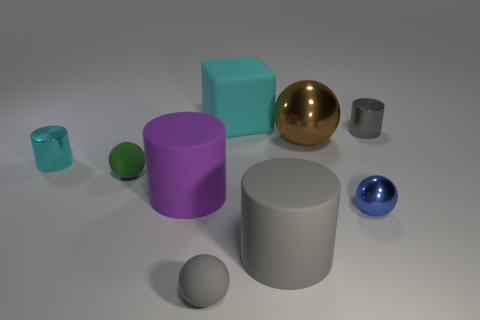The other ball that is made of the same material as the brown sphere is what color?
Your answer should be very brief. Blue. Do the purple matte object and the blue object have the same size?
Your response must be concise. No. What material is the small cyan cylinder?
Your answer should be very brief. Metal. What material is the gray thing that is the same size as the purple rubber cylinder?
Your answer should be very brief. Rubber. Are there any brown balls that have the same size as the cyan metal object?
Offer a terse response. No. Are there an equal number of cyan metal objects right of the cyan block and big blocks on the left side of the tiny gray metal cylinder?
Keep it short and to the point. No. Are there more small cyan things than large green objects?
Offer a very short reply. Yes. How many matte things are tiny cyan things or gray spheres?
Make the answer very short. 1. How many tiny cylinders have the same color as the big block?
Keep it short and to the point. 1. The small green object that is to the right of the cyan object that is in front of the shiny cylinder right of the tiny gray rubber ball is made of what material?
Ensure brevity in your answer.  Rubber. 